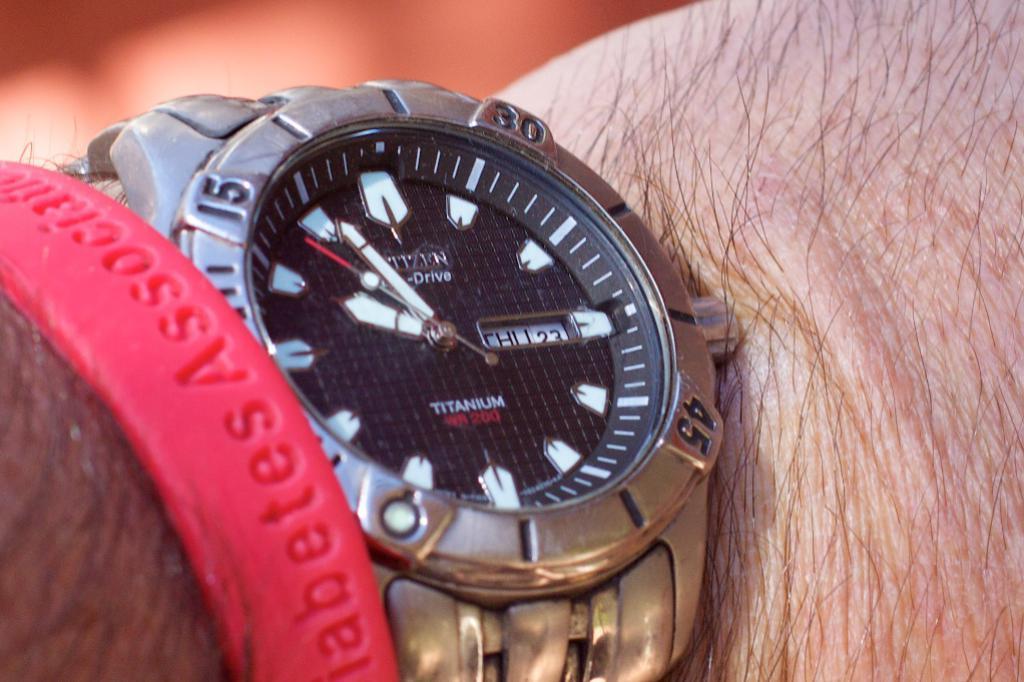Brand name of this watch?
Offer a very short reply. Citizen. What is one of the numbers on the watch?
Your response must be concise. 15. 